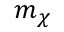Convert formula to latex. <formula><loc_0><loc_0><loc_500><loc_500>m _ { \chi }</formula> 